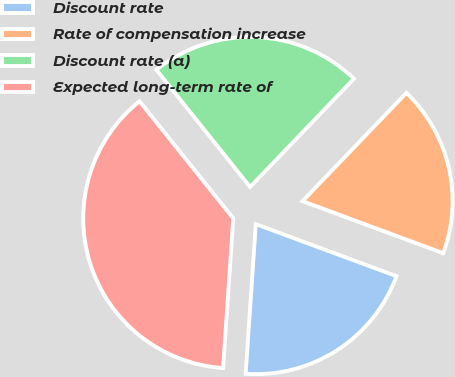<chart> <loc_0><loc_0><loc_500><loc_500><pie_chart><fcel>Discount rate<fcel>Rate of compensation increase<fcel>Discount rate (a)<fcel>Expected long-term rate of<nl><fcel>20.44%<fcel>18.47%<fcel>22.91%<fcel>38.18%<nl></chart> 